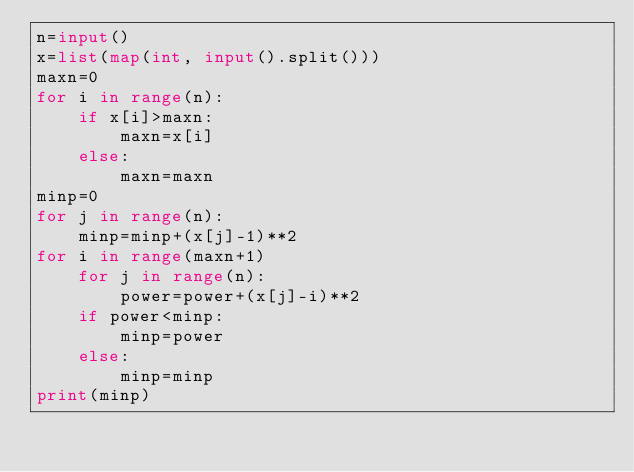Convert code to text. <code><loc_0><loc_0><loc_500><loc_500><_Python_>n=input()
x=list(map(int, input().split()))
maxn=0
for i in range(n):
    if x[i]>maxn:
        maxn=x[i]
    else:
        maxn=maxn
minp=0
for j in range(n):
    minp=minp+(x[j]-1)**2
for i in range(maxn+1)
    for j in range(n):
        power=power+(x[j]-i)**2
    if power<minp:
        minp=power
    else:
        minp=minp
print(minp)</code> 